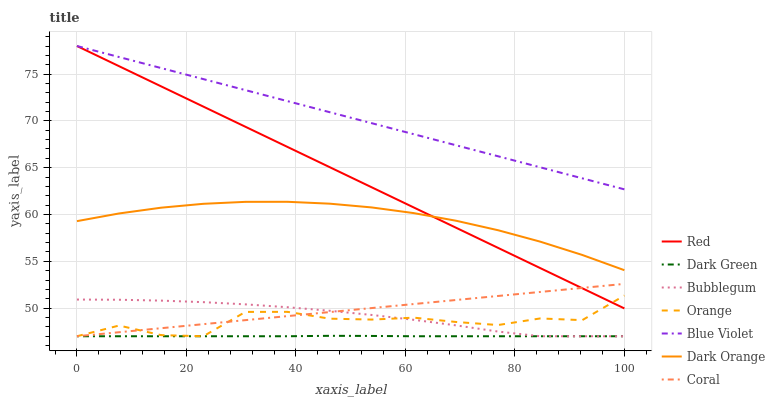Does Dark Green have the minimum area under the curve?
Answer yes or no. Yes. Does Blue Violet have the maximum area under the curve?
Answer yes or no. Yes. Does Coral have the minimum area under the curve?
Answer yes or no. No. Does Coral have the maximum area under the curve?
Answer yes or no. No. Is Red the smoothest?
Answer yes or no. Yes. Is Orange the roughest?
Answer yes or no. Yes. Is Coral the smoothest?
Answer yes or no. No. Is Coral the roughest?
Answer yes or no. No. Does Coral have the lowest value?
Answer yes or no. Yes. Does Red have the lowest value?
Answer yes or no. No. Does Blue Violet have the highest value?
Answer yes or no. Yes. Does Coral have the highest value?
Answer yes or no. No. Is Dark Green less than Dark Orange?
Answer yes or no. Yes. Is Blue Violet greater than Coral?
Answer yes or no. Yes. Does Orange intersect Coral?
Answer yes or no. Yes. Is Orange less than Coral?
Answer yes or no. No. Is Orange greater than Coral?
Answer yes or no. No. Does Dark Green intersect Dark Orange?
Answer yes or no. No. 